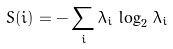Convert formula to latex. <formula><loc_0><loc_0><loc_500><loc_500>S ( i ) = - \sum _ { i } \lambda _ { i } \, \log _ { 2 } \, \lambda _ { i }</formula> 